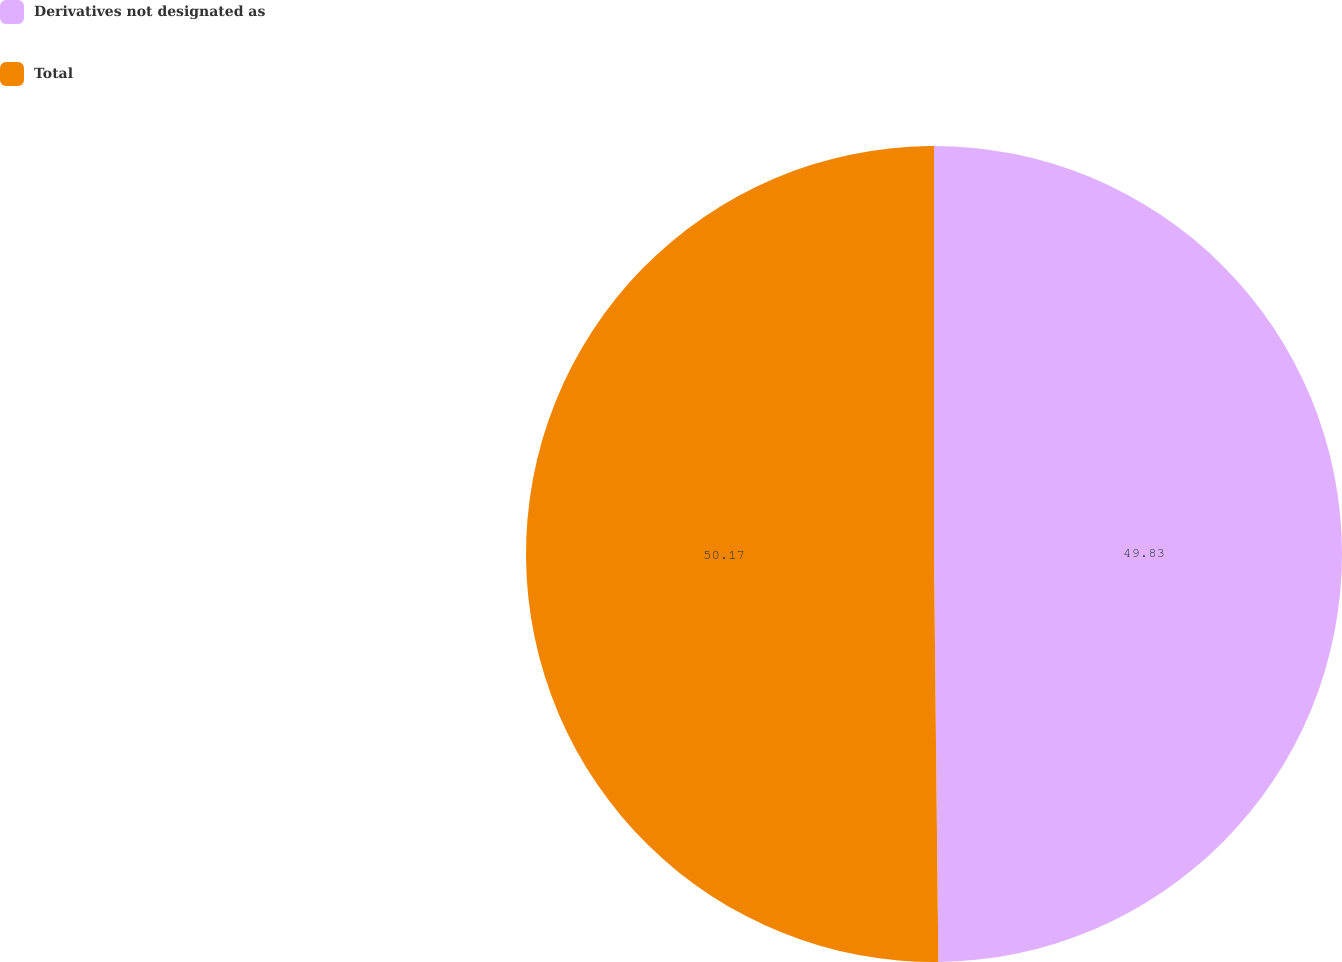<chart> <loc_0><loc_0><loc_500><loc_500><pie_chart><fcel>Derivatives not designated as<fcel>Total<nl><fcel>49.83%<fcel>50.17%<nl></chart> 